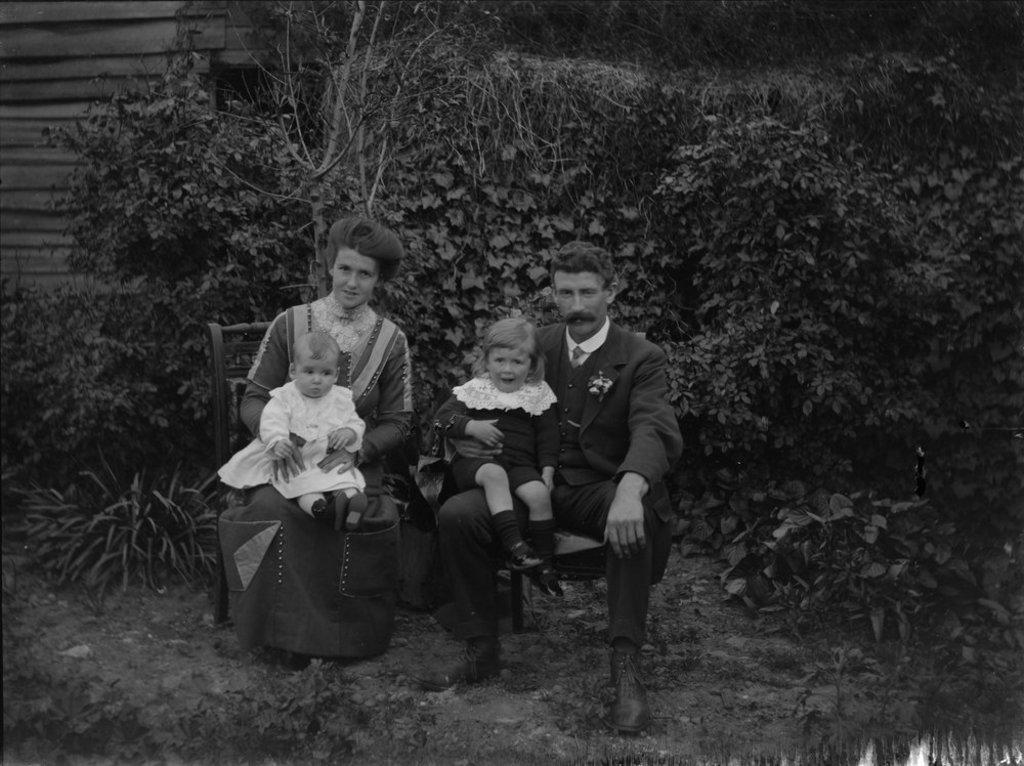Could you give a brief overview of what you see in this image? In the foreground of the picture we can see a family of man, woman and two kids and there are plants. In the background we can see trees and a building. 